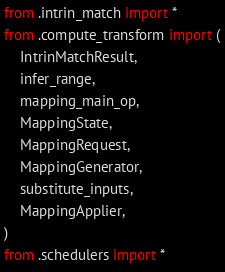Convert code to text. <code><loc_0><loc_0><loc_500><loc_500><_Python_>from .intrin_match import *
from .compute_transform import (
    IntrinMatchResult,
    infer_range,
    mapping_main_op,
    MappingState,
    MappingRequest,
    MappingGenerator,
    substitute_inputs,
    MappingApplier,
)
from .schedulers import *
</code> 